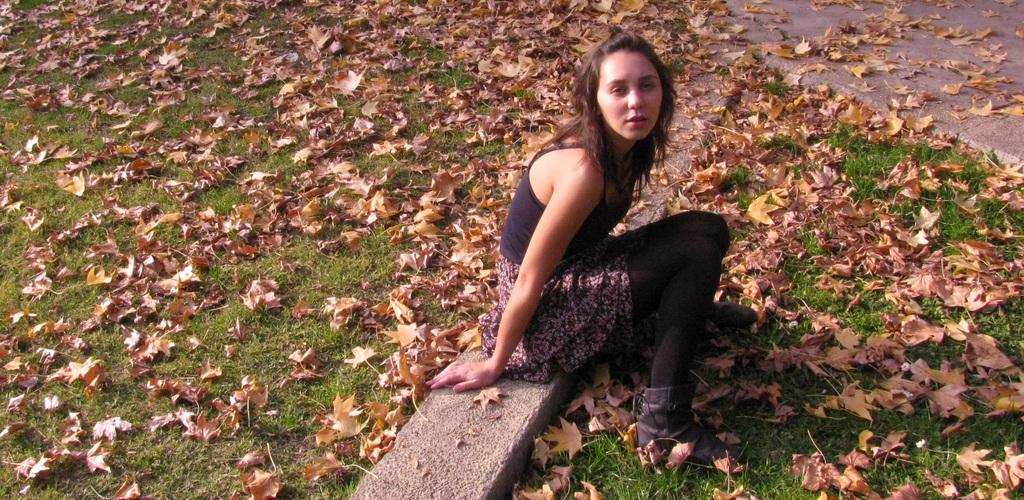What is the woman doing in the image? The woman is sitting in the image. What type of natural environment is visible in the image? There is grass in the image, which suggests a natural setting. What additional elements can be seen in the image? Dry autumn leaves are present in the image. What type of noise can be heard coming from the hospital in the image? There is no hospital present in the image, so it's not possible to determine what, if any, noise might be heard. 